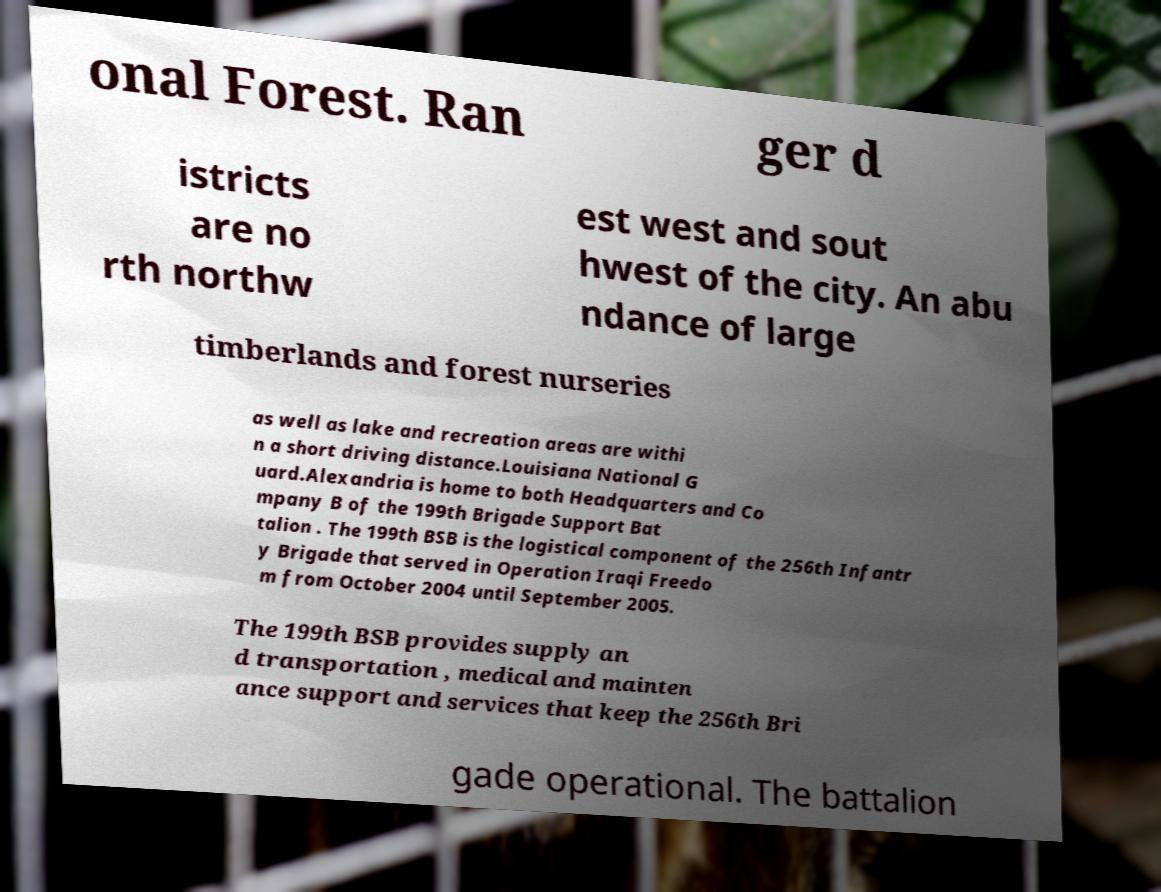There's text embedded in this image that I need extracted. Can you transcribe it verbatim? onal Forest. Ran ger d istricts are no rth northw est west and sout hwest of the city. An abu ndance of large timberlands and forest nurseries as well as lake and recreation areas are withi n a short driving distance.Louisiana National G uard.Alexandria is home to both Headquarters and Co mpany B of the 199th Brigade Support Bat talion . The 199th BSB is the logistical component of the 256th Infantr y Brigade that served in Operation Iraqi Freedo m from October 2004 until September 2005. The 199th BSB provides supply an d transportation , medical and mainten ance support and services that keep the 256th Bri gade operational. The battalion 